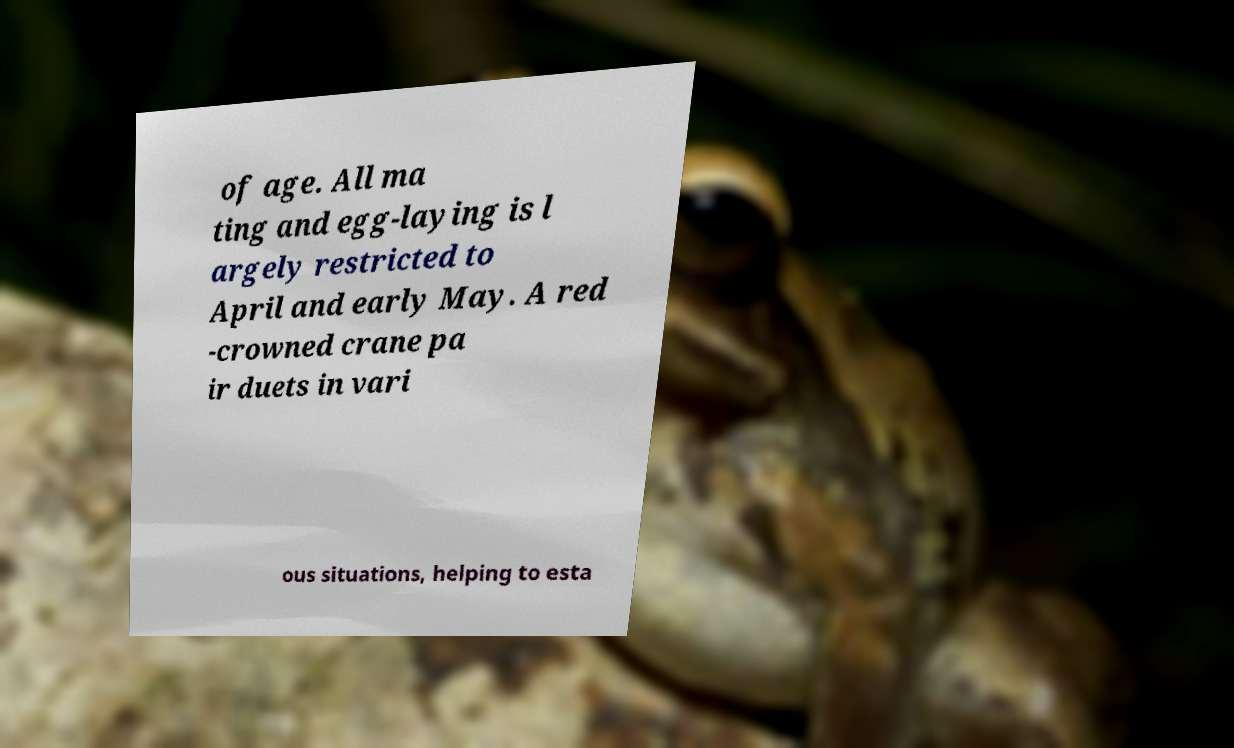Please identify and transcribe the text found in this image. of age. All ma ting and egg-laying is l argely restricted to April and early May. A red -crowned crane pa ir duets in vari ous situations, helping to esta 